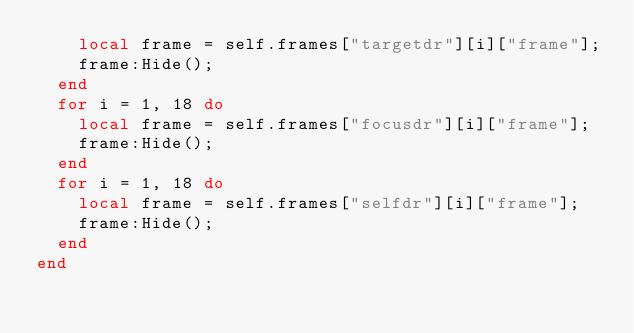<code> <loc_0><loc_0><loc_500><loc_500><_Lua_>		local frame = self.frames["targetdr"][i]["frame"];
		frame:Hide();
	end
	for i = 1, 18 do
		local frame = self.frames["focusdr"][i]["frame"];
		frame:Hide();
	end
	for i = 1, 18 do
		local frame = self.frames["selfdr"][i]["frame"];
		frame:Hide();
	end
end</code> 